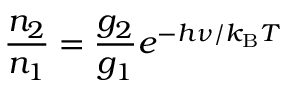<formula> <loc_0><loc_0><loc_500><loc_500>{ \frac { n _ { 2 } } { n _ { 1 } } } = { \frac { g _ { 2 } } { g _ { 1 } } } e ^ { - h \nu / k _ { B } T }</formula> 